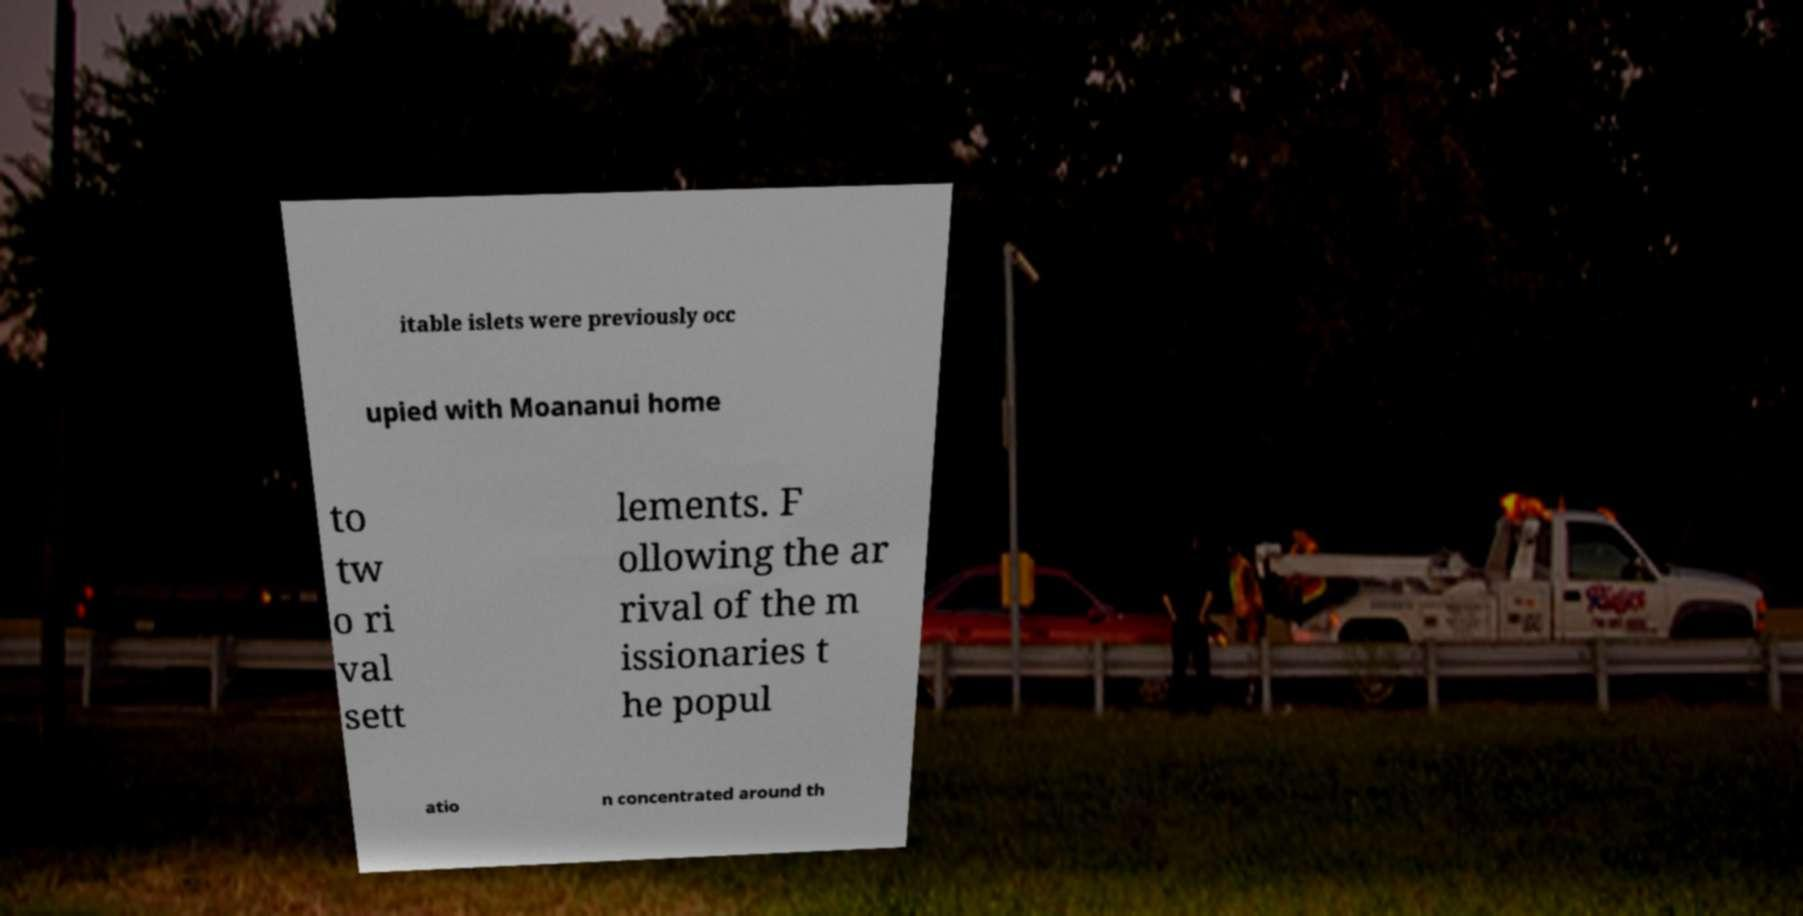For documentation purposes, I need the text within this image transcribed. Could you provide that? itable islets were previously occ upied with Moananui home to tw o ri val sett lements. F ollowing the ar rival of the m issionaries t he popul atio n concentrated around th 